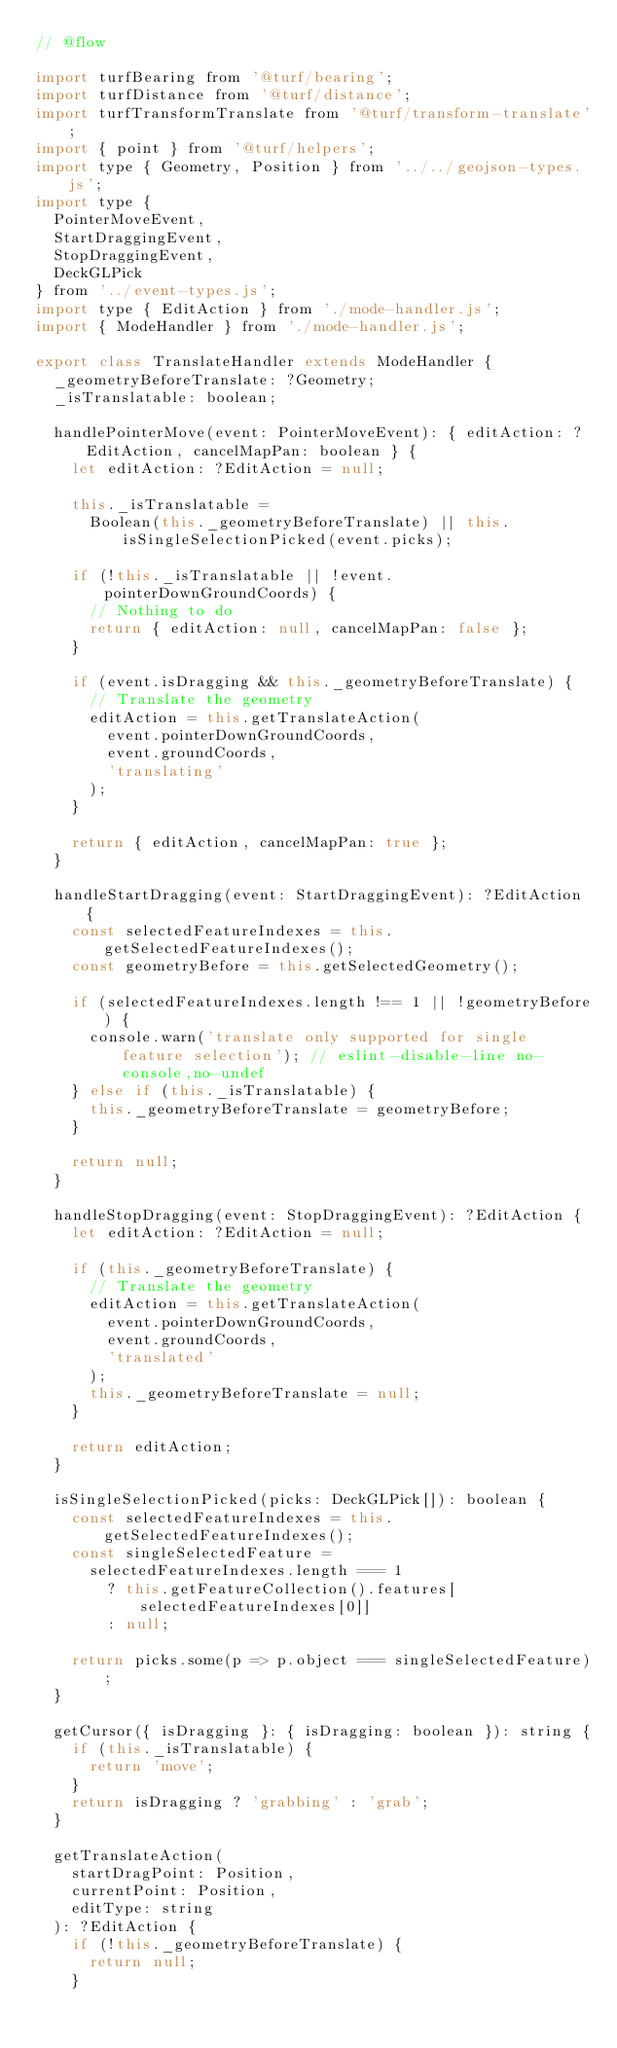<code> <loc_0><loc_0><loc_500><loc_500><_JavaScript_>// @flow

import turfBearing from '@turf/bearing';
import turfDistance from '@turf/distance';
import turfTransformTranslate from '@turf/transform-translate';
import { point } from '@turf/helpers';
import type { Geometry, Position } from '../../geojson-types.js';
import type {
  PointerMoveEvent,
  StartDraggingEvent,
  StopDraggingEvent,
  DeckGLPick
} from '../event-types.js';
import type { EditAction } from './mode-handler.js';
import { ModeHandler } from './mode-handler.js';

export class TranslateHandler extends ModeHandler {
  _geometryBeforeTranslate: ?Geometry;
  _isTranslatable: boolean;

  handlePointerMove(event: PointerMoveEvent): { editAction: ?EditAction, cancelMapPan: boolean } {
    let editAction: ?EditAction = null;

    this._isTranslatable =
      Boolean(this._geometryBeforeTranslate) || this.isSingleSelectionPicked(event.picks);

    if (!this._isTranslatable || !event.pointerDownGroundCoords) {
      // Nothing to do
      return { editAction: null, cancelMapPan: false };
    }

    if (event.isDragging && this._geometryBeforeTranslate) {
      // Translate the geometry
      editAction = this.getTranslateAction(
        event.pointerDownGroundCoords,
        event.groundCoords,
        'translating'
      );
    }

    return { editAction, cancelMapPan: true };
  }

  handleStartDragging(event: StartDraggingEvent): ?EditAction {
    const selectedFeatureIndexes = this.getSelectedFeatureIndexes();
    const geometryBefore = this.getSelectedGeometry();

    if (selectedFeatureIndexes.length !== 1 || !geometryBefore) {
      console.warn('translate only supported for single feature selection'); // eslint-disable-line no-console,no-undef
    } else if (this._isTranslatable) {
      this._geometryBeforeTranslate = geometryBefore;
    }

    return null;
  }

  handleStopDragging(event: StopDraggingEvent): ?EditAction {
    let editAction: ?EditAction = null;

    if (this._geometryBeforeTranslate) {
      // Translate the geometry
      editAction = this.getTranslateAction(
        event.pointerDownGroundCoords,
        event.groundCoords,
        'translated'
      );
      this._geometryBeforeTranslate = null;
    }

    return editAction;
  }

  isSingleSelectionPicked(picks: DeckGLPick[]): boolean {
    const selectedFeatureIndexes = this.getSelectedFeatureIndexes();
    const singleSelectedFeature =
      selectedFeatureIndexes.length === 1
        ? this.getFeatureCollection().features[selectedFeatureIndexes[0]]
        : null;

    return picks.some(p => p.object === singleSelectedFeature);
  }

  getCursor({ isDragging }: { isDragging: boolean }): string {
    if (this._isTranslatable) {
      return 'move';
    }
    return isDragging ? 'grabbing' : 'grab';
  }

  getTranslateAction(
    startDragPoint: Position,
    currentPoint: Position,
    editType: string
  ): ?EditAction {
    if (!this._geometryBeforeTranslate) {
      return null;
    }</code> 